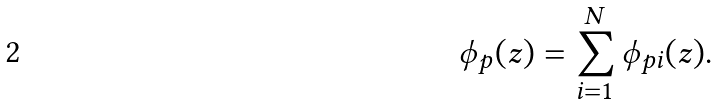Convert formula to latex. <formula><loc_0><loc_0><loc_500><loc_500>\phi _ { p } ( z ) = \sum _ { i = 1 } ^ { N } \phi _ { p i } ( z ) .</formula> 